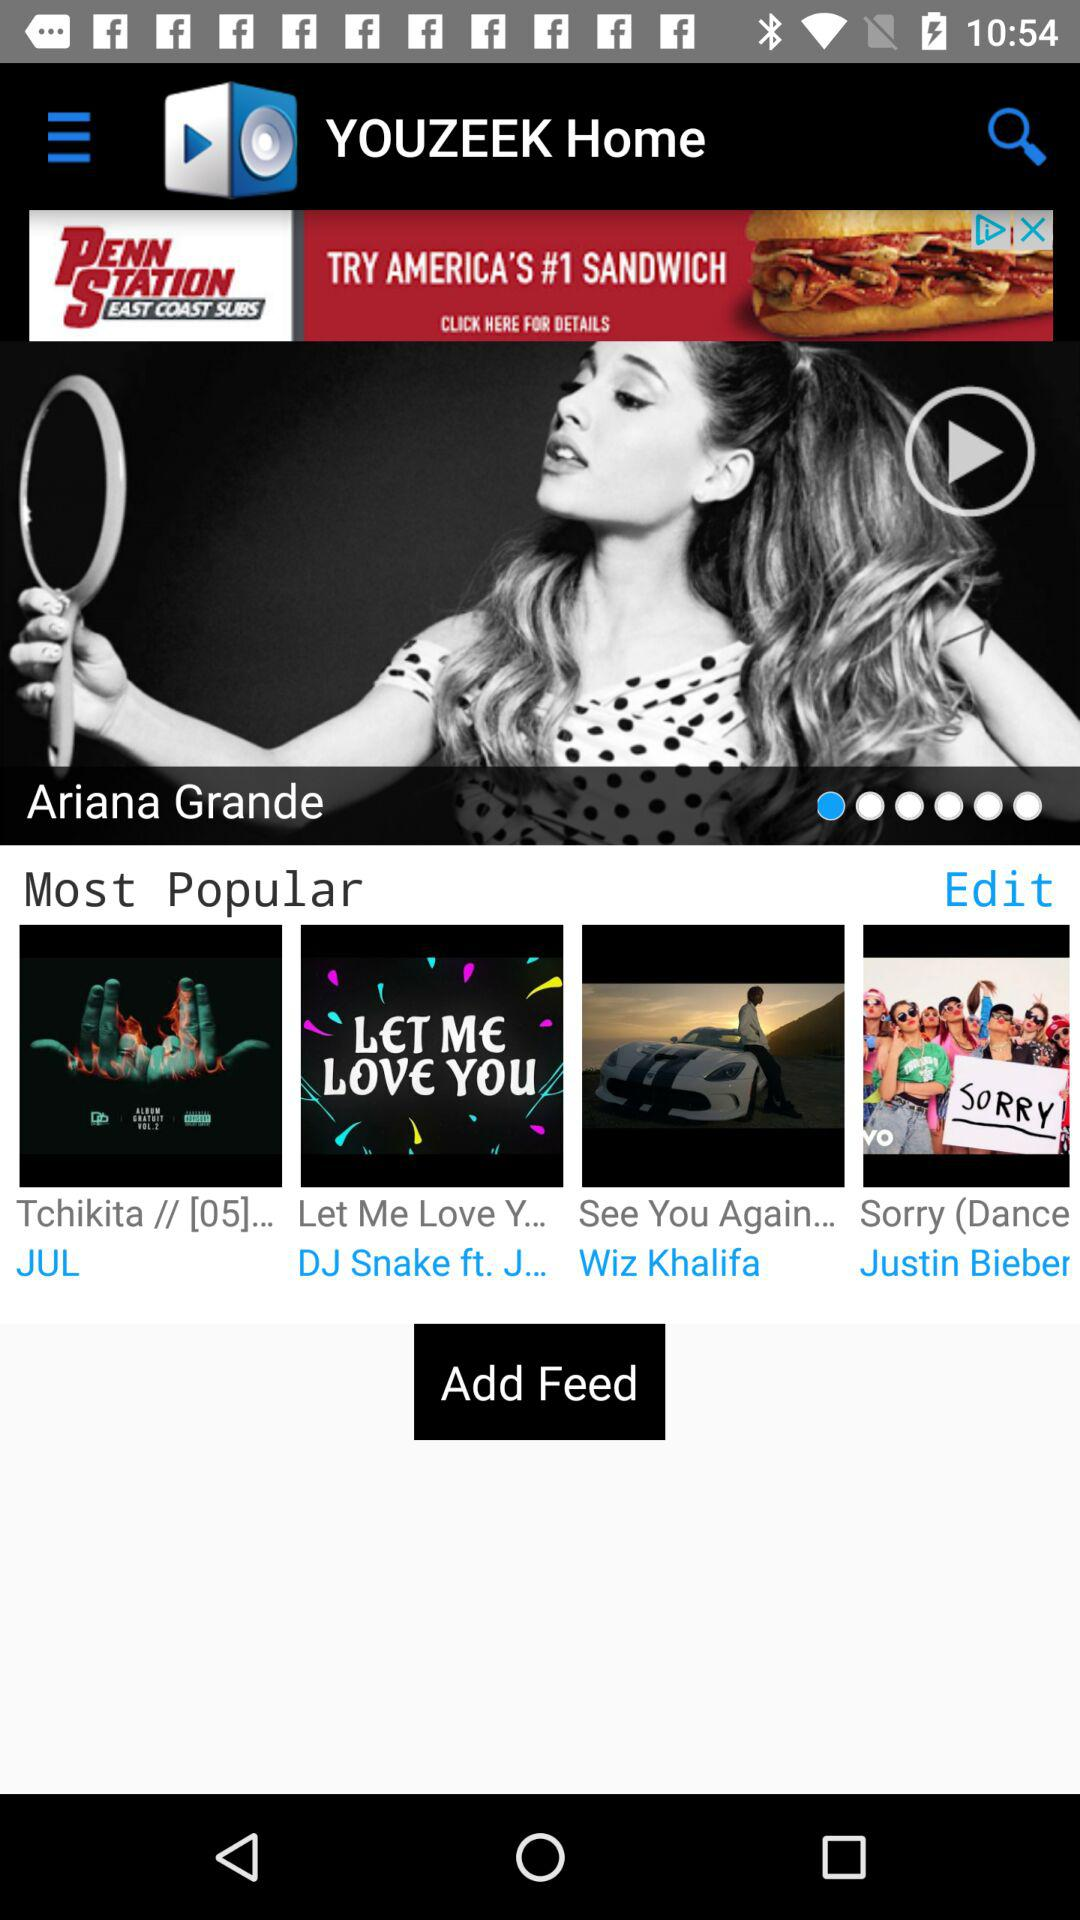What are the most popular songs? The most popular songs are "Tchikita//[05]...", "Let Me Love Y...", "See You Again...", and "Sorry (Dance". 